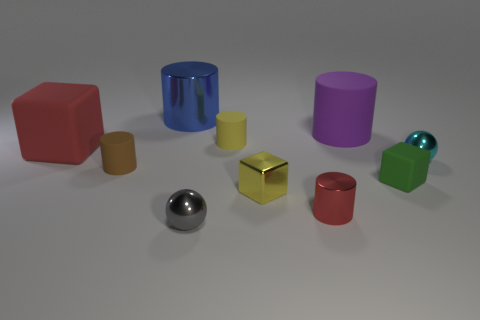There is a tiny metallic sphere to the right of the gray shiny ball; does it have the same color as the tiny matte cylinder that is in front of the big red object?
Ensure brevity in your answer.  No. There is a metal cube that is the same size as the yellow rubber cylinder; what color is it?
Provide a succinct answer. Yellow. Is the number of tiny matte cylinders that are to the left of the small brown thing the same as the number of red objects to the right of the tiny green object?
Keep it short and to the point. Yes. What material is the small sphere that is on the left side of the tiny rubber thing behind the red matte thing?
Give a very brief answer. Metal. How many objects are either gray matte blocks or matte cubes?
Make the answer very short. 2. What is the size of the matte thing that is the same color as the tiny metallic cylinder?
Keep it short and to the point. Large. Are there fewer small gray metal objects than metal things?
Make the answer very short. Yes. What is the size of the cyan object that is made of the same material as the blue cylinder?
Make the answer very short. Small. The gray thing is what size?
Your answer should be compact. Small. What shape is the cyan metal thing?
Your answer should be compact. Sphere. 